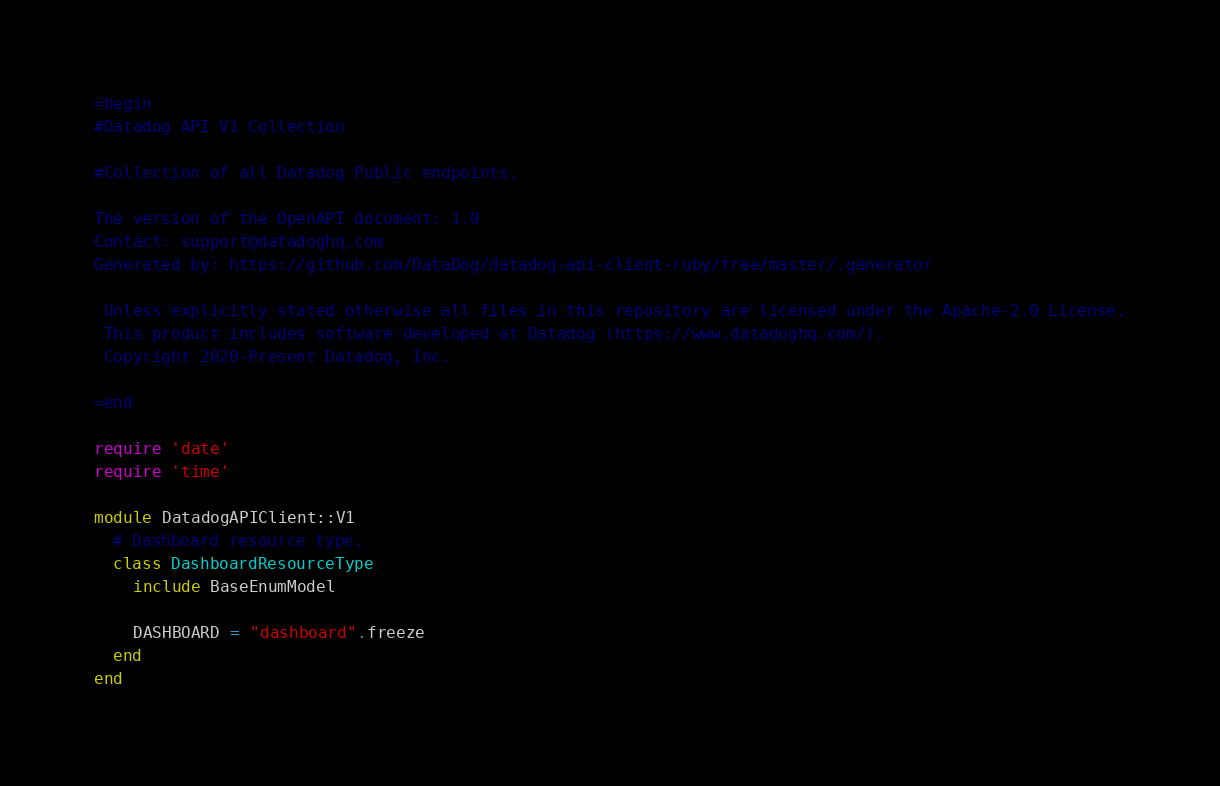Convert code to text. <code><loc_0><loc_0><loc_500><loc_500><_Ruby_>=begin
#Datadog API V1 Collection

#Collection of all Datadog Public endpoints.

The version of the OpenAPI document: 1.0
Contact: support@datadoghq.com
Generated by: https://github.com/DataDog/datadog-api-client-ruby/tree/master/.generator

 Unless explicitly stated otherwise all files in this repository are licensed under the Apache-2.0 License.
 This product includes software developed at Datadog (https://www.datadoghq.com/).
 Copyright 2020-Present Datadog, Inc.

=end

require 'date'
require 'time'

module DatadogAPIClient::V1
  # Dashboard resource type.
  class DashboardResourceType
    include BaseEnumModel

    DASHBOARD = "dashboard".freeze
  end
end
</code> 